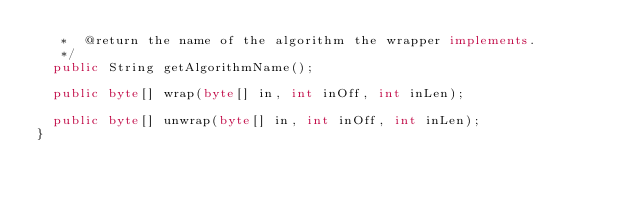<code> <loc_0><loc_0><loc_500><loc_500><_Java_>	 *  @return the name of the algorithm the wrapper implements.
	 */
	public String getAlgorithmName();

	public byte[] wrap(byte[] in, int inOff, int inLen);

	public byte[] unwrap(byte[] in, int inOff, int inLen);
}
</code> 